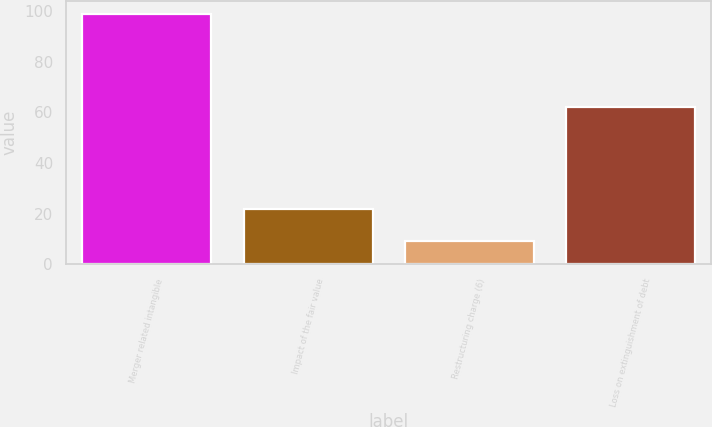<chart> <loc_0><loc_0><loc_500><loc_500><bar_chart><fcel>Merger related intangible<fcel>Impact of the fair value<fcel>Restructuring charge (6)<fcel>Loss on extinguishment of debt<nl><fcel>99<fcel>22<fcel>9<fcel>62<nl></chart> 